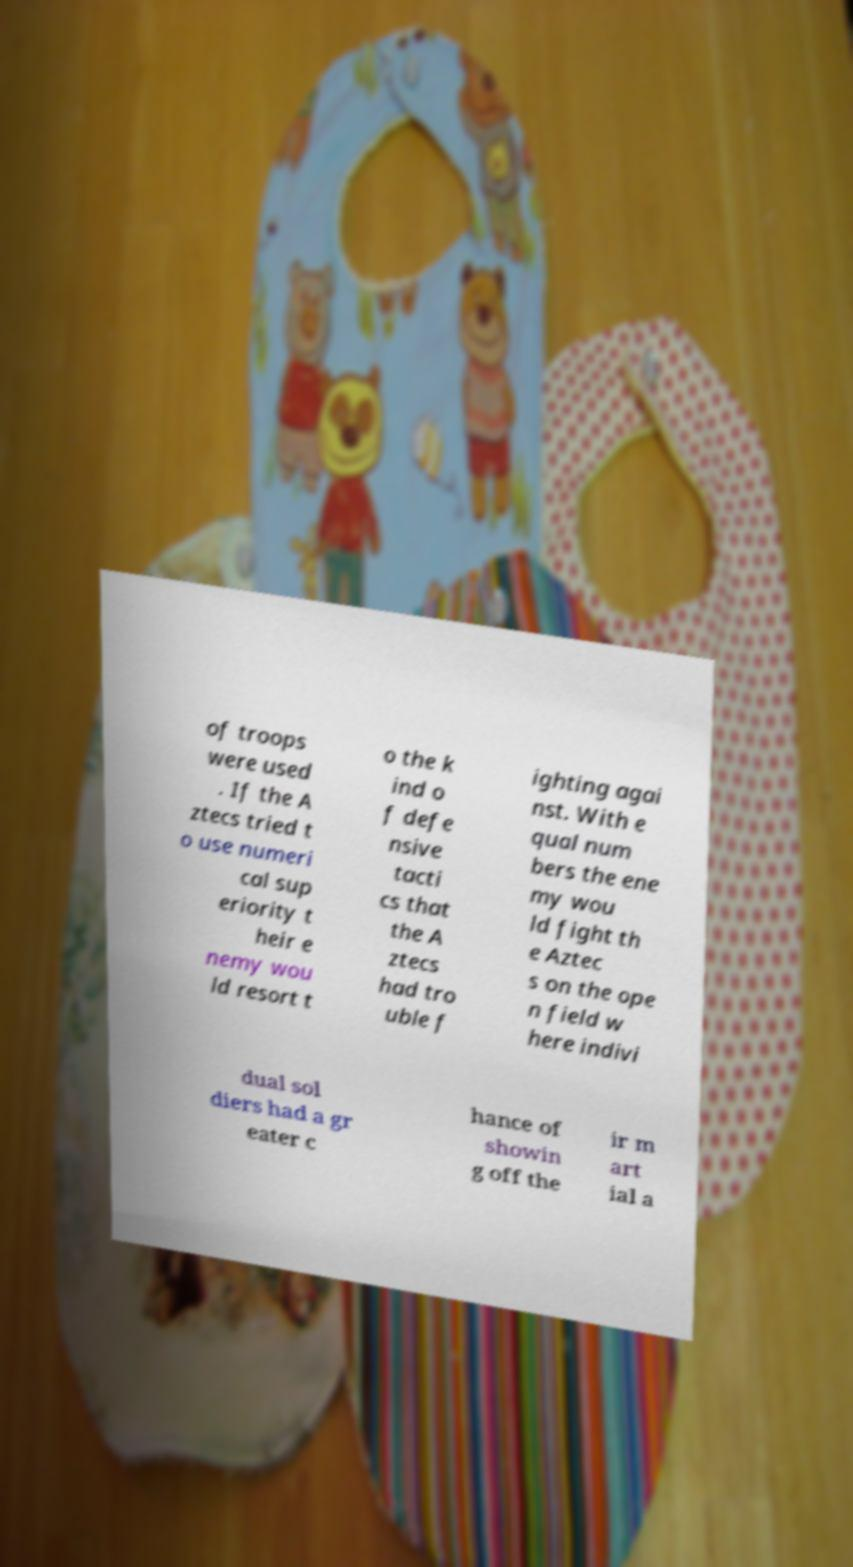What messages or text are displayed in this image? I need them in a readable, typed format. of troops were used . If the A ztecs tried t o use numeri cal sup eriority t heir e nemy wou ld resort t o the k ind o f defe nsive tacti cs that the A ztecs had tro uble f ighting agai nst. With e qual num bers the ene my wou ld fight th e Aztec s on the ope n field w here indivi dual sol diers had a gr eater c hance of showin g off the ir m art ial a 